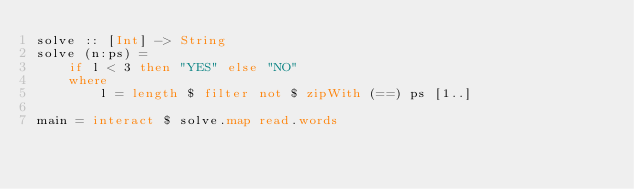<code> <loc_0><loc_0><loc_500><loc_500><_Haskell_>solve :: [Int] -> String
solve (n:ps) = 
    if l < 3 then "YES" else "NO"
    where
        l = length $ filter not $ zipWith (==) ps [1..]

main = interact $ solve.map read.words
</code> 